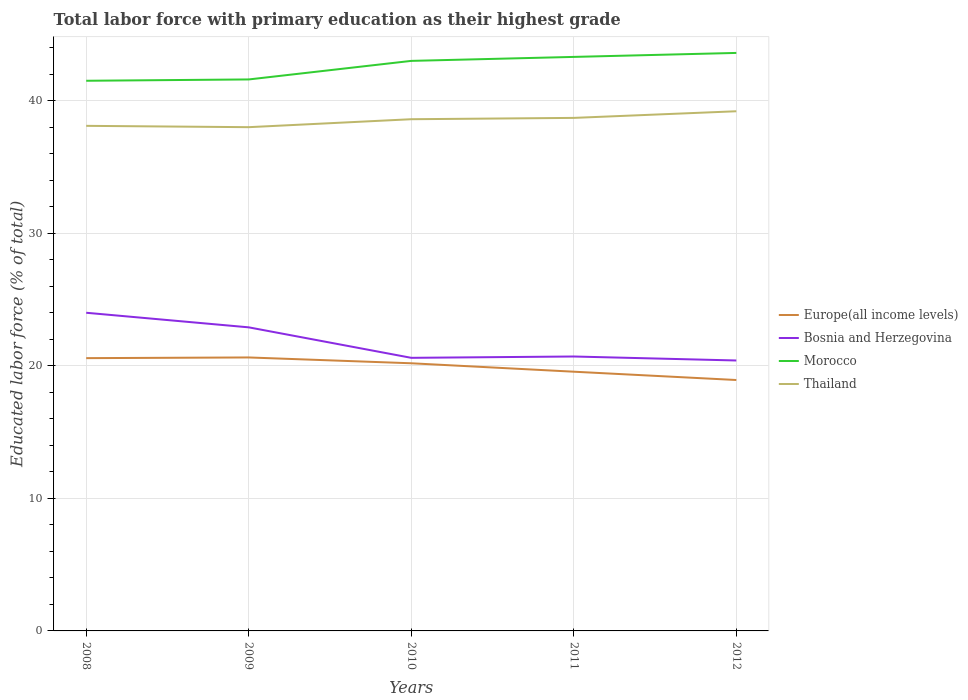Does the line corresponding to Morocco intersect with the line corresponding to Bosnia and Herzegovina?
Offer a terse response. No. Is the number of lines equal to the number of legend labels?
Your response must be concise. Yes. Across all years, what is the maximum percentage of total labor force with primary education in Morocco?
Provide a succinct answer. 41.5. In which year was the percentage of total labor force with primary education in Thailand maximum?
Provide a succinct answer. 2009. What is the total percentage of total labor force with primary education in Thailand in the graph?
Ensure brevity in your answer.  -0.6. What is the difference between the highest and the second highest percentage of total labor force with primary education in Thailand?
Offer a terse response. 1.2. Is the percentage of total labor force with primary education in Morocco strictly greater than the percentage of total labor force with primary education in Thailand over the years?
Give a very brief answer. No. How many lines are there?
Provide a short and direct response. 4. How many years are there in the graph?
Your answer should be very brief. 5. Are the values on the major ticks of Y-axis written in scientific E-notation?
Your response must be concise. No. Does the graph contain grids?
Your answer should be compact. Yes. Where does the legend appear in the graph?
Your response must be concise. Center right. How many legend labels are there?
Make the answer very short. 4. How are the legend labels stacked?
Keep it short and to the point. Vertical. What is the title of the graph?
Offer a terse response. Total labor force with primary education as their highest grade. Does "Pakistan" appear as one of the legend labels in the graph?
Keep it short and to the point. No. What is the label or title of the Y-axis?
Your answer should be compact. Educated labor force (% of total). What is the Educated labor force (% of total) in Europe(all income levels) in 2008?
Ensure brevity in your answer.  20.58. What is the Educated labor force (% of total) of Morocco in 2008?
Keep it short and to the point. 41.5. What is the Educated labor force (% of total) of Thailand in 2008?
Ensure brevity in your answer.  38.1. What is the Educated labor force (% of total) of Europe(all income levels) in 2009?
Offer a terse response. 20.63. What is the Educated labor force (% of total) of Bosnia and Herzegovina in 2009?
Give a very brief answer. 22.9. What is the Educated labor force (% of total) in Morocco in 2009?
Provide a succinct answer. 41.6. What is the Educated labor force (% of total) in Europe(all income levels) in 2010?
Give a very brief answer. 20.19. What is the Educated labor force (% of total) of Bosnia and Herzegovina in 2010?
Ensure brevity in your answer.  20.6. What is the Educated labor force (% of total) in Morocco in 2010?
Provide a succinct answer. 43. What is the Educated labor force (% of total) of Thailand in 2010?
Ensure brevity in your answer.  38.6. What is the Educated labor force (% of total) in Europe(all income levels) in 2011?
Your answer should be very brief. 19.55. What is the Educated labor force (% of total) of Bosnia and Herzegovina in 2011?
Provide a succinct answer. 20.7. What is the Educated labor force (% of total) of Morocco in 2011?
Offer a terse response. 43.3. What is the Educated labor force (% of total) of Thailand in 2011?
Your answer should be very brief. 38.7. What is the Educated labor force (% of total) in Europe(all income levels) in 2012?
Make the answer very short. 18.93. What is the Educated labor force (% of total) of Bosnia and Herzegovina in 2012?
Your response must be concise. 20.4. What is the Educated labor force (% of total) of Morocco in 2012?
Offer a terse response. 43.6. What is the Educated labor force (% of total) in Thailand in 2012?
Offer a very short reply. 39.2. Across all years, what is the maximum Educated labor force (% of total) in Europe(all income levels)?
Keep it short and to the point. 20.63. Across all years, what is the maximum Educated labor force (% of total) of Bosnia and Herzegovina?
Ensure brevity in your answer.  24. Across all years, what is the maximum Educated labor force (% of total) of Morocco?
Ensure brevity in your answer.  43.6. Across all years, what is the maximum Educated labor force (% of total) in Thailand?
Provide a succinct answer. 39.2. Across all years, what is the minimum Educated labor force (% of total) of Europe(all income levels)?
Your answer should be very brief. 18.93. Across all years, what is the minimum Educated labor force (% of total) in Bosnia and Herzegovina?
Give a very brief answer. 20.4. Across all years, what is the minimum Educated labor force (% of total) of Morocco?
Your answer should be very brief. 41.5. Across all years, what is the minimum Educated labor force (% of total) of Thailand?
Ensure brevity in your answer.  38. What is the total Educated labor force (% of total) of Europe(all income levels) in the graph?
Make the answer very short. 99.88. What is the total Educated labor force (% of total) in Bosnia and Herzegovina in the graph?
Your answer should be compact. 108.6. What is the total Educated labor force (% of total) in Morocco in the graph?
Ensure brevity in your answer.  213. What is the total Educated labor force (% of total) of Thailand in the graph?
Offer a very short reply. 192.6. What is the difference between the Educated labor force (% of total) of Europe(all income levels) in 2008 and that in 2009?
Ensure brevity in your answer.  -0.05. What is the difference between the Educated labor force (% of total) in Morocco in 2008 and that in 2009?
Keep it short and to the point. -0.1. What is the difference between the Educated labor force (% of total) of Europe(all income levels) in 2008 and that in 2010?
Provide a succinct answer. 0.39. What is the difference between the Educated labor force (% of total) of Bosnia and Herzegovina in 2008 and that in 2010?
Keep it short and to the point. 3.4. What is the difference between the Educated labor force (% of total) in Morocco in 2008 and that in 2010?
Your response must be concise. -1.5. What is the difference between the Educated labor force (% of total) in Europe(all income levels) in 2008 and that in 2011?
Your answer should be compact. 1.02. What is the difference between the Educated labor force (% of total) of Thailand in 2008 and that in 2011?
Offer a very short reply. -0.6. What is the difference between the Educated labor force (% of total) in Europe(all income levels) in 2008 and that in 2012?
Provide a succinct answer. 1.65. What is the difference between the Educated labor force (% of total) of Morocco in 2008 and that in 2012?
Your answer should be compact. -2.1. What is the difference between the Educated labor force (% of total) of Thailand in 2008 and that in 2012?
Make the answer very short. -1.1. What is the difference between the Educated labor force (% of total) of Europe(all income levels) in 2009 and that in 2010?
Provide a short and direct response. 0.44. What is the difference between the Educated labor force (% of total) of Bosnia and Herzegovina in 2009 and that in 2010?
Your response must be concise. 2.3. What is the difference between the Educated labor force (% of total) in Morocco in 2009 and that in 2010?
Offer a very short reply. -1.4. What is the difference between the Educated labor force (% of total) of Thailand in 2009 and that in 2010?
Your response must be concise. -0.6. What is the difference between the Educated labor force (% of total) of Europe(all income levels) in 2009 and that in 2011?
Ensure brevity in your answer.  1.07. What is the difference between the Educated labor force (% of total) of Thailand in 2009 and that in 2011?
Offer a very short reply. -0.7. What is the difference between the Educated labor force (% of total) in Europe(all income levels) in 2009 and that in 2012?
Make the answer very short. 1.7. What is the difference between the Educated labor force (% of total) of Bosnia and Herzegovina in 2009 and that in 2012?
Offer a terse response. 2.5. What is the difference between the Educated labor force (% of total) in Morocco in 2009 and that in 2012?
Make the answer very short. -2. What is the difference between the Educated labor force (% of total) of Europe(all income levels) in 2010 and that in 2011?
Your answer should be very brief. 0.64. What is the difference between the Educated labor force (% of total) in Morocco in 2010 and that in 2011?
Keep it short and to the point. -0.3. What is the difference between the Educated labor force (% of total) of Europe(all income levels) in 2010 and that in 2012?
Offer a very short reply. 1.26. What is the difference between the Educated labor force (% of total) of Bosnia and Herzegovina in 2010 and that in 2012?
Your response must be concise. 0.2. What is the difference between the Educated labor force (% of total) in Thailand in 2010 and that in 2012?
Your answer should be very brief. -0.6. What is the difference between the Educated labor force (% of total) of Europe(all income levels) in 2011 and that in 2012?
Give a very brief answer. 0.63. What is the difference between the Educated labor force (% of total) of Bosnia and Herzegovina in 2011 and that in 2012?
Make the answer very short. 0.3. What is the difference between the Educated labor force (% of total) in Morocco in 2011 and that in 2012?
Offer a very short reply. -0.3. What is the difference between the Educated labor force (% of total) in Thailand in 2011 and that in 2012?
Offer a terse response. -0.5. What is the difference between the Educated labor force (% of total) in Europe(all income levels) in 2008 and the Educated labor force (% of total) in Bosnia and Herzegovina in 2009?
Your answer should be very brief. -2.32. What is the difference between the Educated labor force (% of total) in Europe(all income levels) in 2008 and the Educated labor force (% of total) in Morocco in 2009?
Keep it short and to the point. -21.02. What is the difference between the Educated labor force (% of total) in Europe(all income levels) in 2008 and the Educated labor force (% of total) in Thailand in 2009?
Provide a short and direct response. -17.42. What is the difference between the Educated labor force (% of total) in Bosnia and Herzegovina in 2008 and the Educated labor force (% of total) in Morocco in 2009?
Keep it short and to the point. -17.6. What is the difference between the Educated labor force (% of total) in Morocco in 2008 and the Educated labor force (% of total) in Thailand in 2009?
Provide a succinct answer. 3.5. What is the difference between the Educated labor force (% of total) in Europe(all income levels) in 2008 and the Educated labor force (% of total) in Bosnia and Herzegovina in 2010?
Your answer should be compact. -0.02. What is the difference between the Educated labor force (% of total) of Europe(all income levels) in 2008 and the Educated labor force (% of total) of Morocco in 2010?
Offer a terse response. -22.42. What is the difference between the Educated labor force (% of total) in Europe(all income levels) in 2008 and the Educated labor force (% of total) in Thailand in 2010?
Your response must be concise. -18.02. What is the difference between the Educated labor force (% of total) of Bosnia and Herzegovina in 2008 and the Educated labor force (% of total) of Thailand in 2010?
Your response must be concise. -14.6. What is the difference between the Educated labor force (% of total) in Morocco in 2008 and the Educated labor force (% of total) in Thailand in 2010?
Your response must be concise. 2.9. What is the difference between the Educated labor force (% of total) in Europe(all income levels) in 2008 and the Educated labor force (% of total) in Bosnia and Herzegovina in 2011?
Offer a very short reply. -0.12. What is the difference between the Educated labor force (% of total) of Europe(all income levels) in 2008 and the Educated labor force (% of total) of Morocco in 2011?
Provide a short and direct response. -22.72. What is the difference between the Educated labor force (% of total) of Europe(all income levels) in 2008 and the Educated labor force (% of total) of Thailand in 2011?
Offer a terse response. -18.12. What is the difference between the Educated labor force (% of total) of Bosnia and Herzegovina in 2008 and the Educated labor force (% of total) of Morocco in 2011?
Make the answer very short. -19.3. What is the difference between the Educated labor force (% of total) of Bosnia and Herzegovina in 2008 and the Educated labor force (% of total) of Thailand in 2011?
Your answer should be compact. -14.7. What is the difference between the Educated labor force (% of total) in Morocco in 2008 and the Educated labor force (% of total) in Thailand in 2011?
Provide a succinct answer. 2.8. What is the difference between the Educated labor force (% of total) of Europe(all income levels) in 2008 and the Educated labor force (% of total) of Bosnia and Herzegovina in 2012?
Give a very brief answer. 0.18. What is the difference between the Educated labor force (% of total) in Europe(all income levels) in 2008 and the Educated labor force (% of total) in Morocco in 2012?
Give a very brief answer. -23.02. What is the difference between the Educated labor force (% of total) of Europe(all income levels) in 2008 and the Educated labor force (% of total) of Thailand in 2012?
Your response must be concise. -18.62. What is the difference between the Educated labor force (% of total) in Bosnia and Herzegovina in 2008 and the Educated labor force (% of total) in Morocco in 2012?
Your answer should be very brief. -19.6. What is the difference between the Educated labor force (% of total) in Bosnia and Herzegovina in 2008 and the Educated labor force (% of total) in Thailand in 2012?
Keep it short and to the point. -15.2. What is the difference between the Educated labor force (% of total) in Europe(all income levels) in 2009 and the Educated labor force (% of total) in Bosnia and Herzegovina in 2010?
Ensure brevity in your answer.  0.03. What is the difference between the Educated labor force (% of total) of Europe(all income levels) in 2009 and the Educated labor force (% of total) of Morocco in 2010?
Your answer should be very brief. -22.37. What is the difference between the Educated labor force (% of total) in Europe(all income levels) in 2009 and the Educated labor force (% of total) in Thailand in 2010?
Ensure brevity in your answer.  -17.97. What is the difference between the Educated labor force (% of total) in Bosnia and Herzegovina in 2009 and the Educated labor force (% of total) in Morocco in 2010?
Provide a succinct answer. -20.1. What is the difference between the Educated labor force (% of total) in Bosnia and Herzegovina in 2009 and the Educated labor force (% of total) in Thailand in 2010?
Keep it short and to the point. -15.7. What is the difference between the Educated labor force (% of total) in Morocco in 2009 and the Educated labor force (% of total) in Thailand in 2010?
Your answer should be compact. 3. What is the difference between the Educated labor force (% of total) of Europe(all income levels) in 2009 and the Educated labor force (% of total) of Bosnia and Herzegovina in 2011?
Provide a succinct answer. -0.07. What is the difference between the Educated labor force (% of total) of Europe(all income levels) in 2009 and the Educated labor force (% of total) of Morocco in 2011?
Offer a very short reply. -22.67. What is the difference between the Educated labor force (% of total) of Europe(all income levels) in 2009 and the Educated labor force (% of total) of Thailand in 2011?
Your response must be concise. -18.07. What is the difference between the Educated labor force (% of total) of Bosnia and Herzegovina in 2009 and the Educated labor force (% of total) of Morocco in 2011?
Provide a short and direct response. -20.4. What is the difference between the Educated labor force (% of total) of Bosnia and Herzegovina in 2009 and the Educated labor force (% of total) of Thailand in 2011?
Keep it short and to the point. -15.8. What is the difference between the Educated labor force (% of total) in Morocco in 2009 and the Educated labor force (% of total) in Thailand in 2011?
Your answer should be compact. 2.9. What is the difference between the Educated labor force (% of total) of Europe(all income levels) in 2009 and the Educated labor force (% of total) of Bosnia and Herzegovina in 2012?
Offer a terse response. 0.23. What is the difference between the Educated labor force (% of total) in Europe(all income levels) in 2009 and the Educated labor force (% of total) in Morocco in 2012?
Your answer should be very brief. -22.97. What is the difference between the Educated labor force (% of total) of Europe(all income levels) in 2009 and the Educated labor force (% of total) of Thailand in 2012?
Give a very brief answer. -18.57. What is the difference between the Educated labor force (% of total) of Bosnia and Herzegovina in 2009 and the Educated labor force (% of total) of Morocco in 2012?
Keep it short and to the point. -20.7. What is the difference between the Educated labor force (% of total) in Bosnia and Herzegovina in 2009 and the Educated labor force (% of total) in Thailand in 2012?
Make the answer very short. -16.3. What is the difference between the Educated labor force (% of total) in Europe(all income levels) in 2010 and the Educated labor force (% of total) in Bosnia and Herzegovina in 2011?
Keep it short and to the point. -0.51. What is the difference between the Educated labor force (% of total) in Europe(all income levels) in 2010 and the Educated labor force (% of total) in Morocco in 2011?
Ensure brevity in your answer.  -23.11. What is the difference between the Educated labor force (% of total) in Europe(all income levels) in 2010 and the Educated labor force (% of total) in Thailand in 2011?
Make the answer very short. -18.51. What is the difference between the Educated labor force (% of total) of Bosnia and Herzegovina in 2010 and the Educated labor force (% of total) of Morocco in 2011?
Provide a short and direct response. -22.7. What is the difference between the Educated labor force (% of total) of Bosnia and Herzegovina in 2010 and the Educated labor force (% of total) of Thailand in 2011?
Offer a terse response. -18.1. What is the difference between the Educated labor force (% of total) in Europe(all income levels) in 2010 and the Educated labor force (% of total) in Bosnia and Herzegovina in 2012?
Give a very brief answer. -0.21. What is the difference between the Educated labor force (% of total) of Europe(all income levels) in 2010 and the Educated labor force (% of total) of Morocco in 2012?
Offer a terse response. -23.41. What is the difference between the Educated labor force (% of total) in Europe(all income levels) in 2010 and the Educated labor force (% of total) in Thailand in 2012?
Make the answer very short. -19.01. What is the difference between the Educated labor force (% of total) in Bosnia and Herzegovina in 2010 and the Educated labor force (% of total) in Morocco in 2012?
Your response must be concise. -23. What is the difference between the Educated labor force (% of total) in Bosnia and Herzegovina in 2010 and the Educated labor force (% of total) in Thailand in 2012?
Offer a very short reply. -18.6. What is the difference between the Educated labor force (% of total) in Morocco in 2010 and the Educated labor force (% of total) in Thailand in 2012?
Your response must be concise. 3.8. What is the difference between the Educated labor force (% of total) in Europe(all income levels) in 2011 and the Educated labor force (% of total) in Bosnia and Herzegovina in 2012?
Your answer should be very brief. -0.85. What is the difference between the Educated labor force (% of total) in Europe(all income levels) in 2011 and the Educated labor force (% of total) in Morocco in 2012?
Keep it short and to the point. -24.05. What is the difference between the Educated labor force (% of total) in Europe(all income levels) in 2011 and the Educated labor force (% of total) in Thailand in 2012?
Your response must be concise. -19.65. What is the difference between the Educated labor force (% of total) in Bosnia and Herzegovina in 2011 and the Educated labor force (% of total) in Morocco in 2012?
Offer a terse response. -22.9. What is the difference between the Educated labor force (% of total) in Bosnia and Herzegovina in 2011 and the Educated labor force (% of total) in Thailand in 2012?
Provide a short and direct response. -18.5. What is the difference between the Educated labor force (% of total) in Morocco in 2011 and the Educated labor force (% of total) in Thailand in 2012?
Make the answer very short. 4.1. What is the average Educated labor force (% of total) of Europe(all income levels) per year?
Offer a very short reply. 19.98. What is the average Educated labor force (% of total) in Bosnia and Herzegovina per year?
Ensure brevity in your answer.  21.72. What is the average Educated labor force (% of total) of Morocco per year?
Offer a terse response. 42.6. What is the average Educated labor force (% of total) of Thailand per year?
Offer a terse response. 38.52. In the year 2008, what is the difference between the Educated labor force (% of total) in Europe(all income levels) and Educated labor force (% of total) in Bosnia and Herzegovina?
Your answer should be compact. -3.42. In the year 2008, what is the difference between the Educated labor force (% of total) of Europe(all income levels) and Educated labor force (% of total) of Morocco?
Give a very brief answer. -20.92. In the year 2008, what is the difference between the Educated labor force (% of total) in Europe(all income levels) and Educated labor force (% of total) in Thailand?
Make the answer very short. -17.52. In the year 2008, what is the difference between the Educated labor force (% of total) of Bosnia and Herzegovina and Educated labor force (% of total) of Morocco?
Your answer should be compact. -17.5. In the year 2008, what is the difference between the Educated labor force (% of total) in Bosnia and Herzegovina and Educated labor force (% of total) in Thailand?
Ensure brevity in your answer.  -14.1. In the year 2008, what is the difference between the Educated labor force (% of total) of Morocco and Educated labor force (% of total) of Thailand?
Provide a succinct answer. 3.4. In the year 2009, what is the difference between the Educated labor force (% of total) in Europe(all income levels) and Educated labor force (% of total) in Bosnia and Herzegovina?
Keep it short and to the point. -2.27. In the year 2009, what is the difference between the Educated labor force (% of total) in Europe(all income levels) and Educated labor force (% of total) in Morocco?
Offer a very short reply. -20.97. In the year 2009, what is the difference between the Educated labor force (% of total) of Europe(all income levels) and Educated labor force (% of total) of Thailand?
Make the answer very short. -17.37. In the year 2009, what is the difference between the Educated labor force (% of total) in Bosnia and Herzegovina and Educated labor force (% of total) in Morocco?
Keep it short and to the point. -18.7. In the year 2009, what is the difference between the Educated labor force (% of total) in Bosnia and Herzegovina and Educated labor force (% of total) in Thailand?
Give a very brief answer. -15.1. In the year 2009, what is the difference between the Educated labor force (% of total) in Morocco and Educated labor force (% of total) in Thailand?
Provide a short and direct response. 3.6. In the year 2010, what is the difference between the Educated labor force (% of total) in Europe(all income levels) and Educated labor force (% of total) in Bosnia and Herzegovina?
Make the answer very short. -0.41. In the year 2010, what is the difference between the Educated labor force (% of total) of Europe(all income levels) and Educated labor force (% of total) of Morocco?
Provide a short and direct response. -22.81. In the year 2010, what is the difference between the Educated labor force (% of total) of Europe(all income levels) and Educated labor force (% of total) of Thailand?
Your answer should be compact. -18.41. In the year 2010, what is the difference between the Educated labor force (% of total) in Bosnia and Herzegovina and Educated labor force (% of total) in Morocco?
Provide a succinct answer. -22.4. In the year 2010, what is the difference between the Educated labor force (% of total) of Bosnia and Herzegovina and Educated labor force (% of total) of Thailand?
Your answer should be compact. -18. In the year 2010, what is the difference between the Educated labor force (% of total) of Morocco and Educated labor force (% of total) of Thailand?
Offer a terse response. 4.4. In the year 2011, what is the difference between the Educated labor force (% of total) in Europe(all income levels) and Educated labor force (% of total) in Bosnia and Herzegovina?
Make the answer very short. -1.15. In the year 2011, what is the difference between the Educated labor force (% of total) in Europe(all income levels) and Educated labor force (% of total) in Morocco?
Your response must be concise. -23.75. In the year 2011, what is the difference between the Educated labor force (% of total) in Europe(all income levels) and Educated labor force (% of total) in Thailand?
Your response must be concise. -19.15. In the year 2011, what is the difference between the Educated labor force (% of total) of Bosnia and Herzegovina and Educated labor force (% of total) of Morocco?
Your response must be concise. -22.6. In the year 2011, what is the difference between the Educated labor force (% of total) in Bosnia and Herzegovina and Educated labor force (% of total) in Thailand?
Your response must be concise. -18. In the year 2011, what is the difference between the Educated labor force (% of total) in Morocco and Educated labor force (% of total) in Thailand?
Provide a succinct answer. 4.6. In the year 2012, what is the difference between the Educated labor force (% of total) of Europe(all income levels) and Educated labor force (% of total) of Bosnia and Herzegovina?
Provide a short and direct response. -1.47. In the year 2012, what is the difference between the Educated labor force (% of total) in Europe(all income levels) and Educated labor force (% of total) in Morocco?
Make the answer very short. -24.67. In the year 2012, what is the difference between the Educated labor force (% of total) in Europe(all income levels) and Educated labor force (% of total) in Thailand?
Provide a succinct answer. -20.27. In the year 2012, what is the difference between the Educated labor force (% of total) in Bosnia and Herzegovina and Educated labor force (% of total) in Morocco?
Provide a succinct answer. -23.2. In the year 2012, what is the difference between the Educated labor force (% of total) of Bosnia and Herzegovina and Educated labor force (% of total) of Thailand?
Ensure brevity in your answer.  -18.8. What is the ratio of the Educated labor force (% of total) of Europe(all income levels) in 2008 to that in 2009?
Keep it short and to the point. 1. What is the ratio of the Educated labor force (% of total) in Bosnia and Herzegovina in 2008 to that in 2009?
Keep it short and to the point. 1.05. What is the ratio of the Educated labor force (% of total) of Morocco in 2008 to that in 2009?
Give a very brief answer. 1. What is the ratio of the Educated labor force (% of total) of Thailand in 2008 to that in 2009?
Provide a succinct answer. 1. What is the ratio of the Educated labor force (% of total) of Europe(all income levels) in 2008 to that in 2010?
Ensure brevity in your answer.  1.02. What is the ratio of the Educated labor force (% of total) in Bosnia and Herzegovina in 2008 to that in 2010?
Provide a succinct answer. 1.17. What is the ratio of the Educated labor force (% of total) of Morocco in 2008 to that in 2010?
Provide a succinct answer. 0.97. What is the ratio of the Educated labor force (% of total) in Europe(all income levels) in 2008 to that in 2011?
Your response must be concise. 1.05. What is the ratio of the Educated labor force (% of total) in Bosnia and Herzegovina in 2008 to that in 2011?
Offer a terse response. 1.16. What is the ratio of the Educated labor force (% of total) in Morocco in 2008 to that in 2011?
Your answer should be compact. 0.96. What is the ratio of the Educated labor force (% of total) of Thailand in 2008 to that in 2011?
Make the answer very short. 0.98. What is the ratio of the Educated labor force (% of total) of Europe(all income levels) in 2008 to that in 2012?
Offer a very short reply. 1.09. What is the ratio of the Educated labor force (% of total) in Bosnia and Herzegovina in 2008 to that in 2012?
Provide a short and direct response. 1.18. What is the ratio of the Educated labor force (% of total) in Morocco in 2008 to that in 2012?
Provide a succinct answer. 0.95. What is the ratio of the Educated labor force (% of total) in Thailand in 2008 to that in 2012?
Provide a succinct answer. 0.97. What is the ratio of the Educated labor force (% of total) of Europe(all income levels) in 2009 to that in 2010?
Ensure brevity in your answer.  1.02. What is the ratio of the Educated labor force (% of total) in Bosnia and Herzegovina in 2009 to that in 2010?
Give a very brief answer. 1.11. What is the ratio of the Educated labor force (% of total) in Morocco in 2009 to that in 2010?
Offer a terse response. 0.97. What is the ratio of the Educated labor force (% of total) in Thailand in 2009 to that in 2010?
Give a very brief answer. 0.98. What is the ratio of the Educated labor force (% of total) of Europe(all income levels) in 2009 to that in 2011?
Your response must be concise. 1.05. What is the ratio of the Educated labor force (% of total) of Bosnia and Herzegovina in 2009 to that in 2011?
Your answer should be compact. 1.11. What is the ratio of the Educated labor force (% of total) in Morocco in 2009 to that in 2011?
Your answer should be very brief. 0.96. What is the ratio of the Educated labor force (% of total) of Thailand in 2009 to that in 2011?
Make the answer very short. 0.98. What is the ratio of the Educated labor force (% of total) in Europe(all income levels) in 2009 to that in 2012?
Keep it short and to the point. 1.09. What is the ratio of the Educated labor force (% of total) of Bosnia and Herzegovina in 2009 to that in 2012?
Your answer should be very brief. 1.12. What is the ratio of the Educated labor force (% of total) in Morocco in 2009 to that in 2012?
Keep it short and to the point. 0.95. What is the ratio of the Educated labor force (% of total) of Thailand in 2009 to that in 2012?
Your answer should be very brief. 0.97. What is the ratio of the Educated labor force (% of total) of Europe(all income levels) in 2010 to that in 2011?
Your response must be concise. 1.03. What is the ratio of the Educated labor force (% of total) of Bosnia and Herzegovina in 2010 to that in 2011?
Offer a terse response. 1. What is the ratio of the Educated labor force (% of total) in Morocco in 2010 to that in 2011?
Ensure brevity in your answer.  0.99. What is the ratio of the Educated labor force (% of total) in Thailand in 2010 to that in 2011?
Your response must be concise. 1. What is the ratio of the Educated labor force (% of total) of Europe(all income levels) in 2010 to that in 2012?
Ensure brevity in your answer.  1.07. What is the ratio of the Educated labor force (% of total) in Bosnia and Herzegovina in 2010 to that in 2012?
Ensure brevity in your answer.  1.01. What is the ratio of the Educated labor force (% of total) of Morocco in 2010 to that in 2012?
Keep it short and to the point. 0.99. What is the ratio of the Educated labor force (% of total) of Thailand in 2010 to that in 2012?
Make the answer very short. 0.98. What is the ratio of the Educated labor force (% of total) in Europe(all income levels) in 2011 to that in 2012?
Your response must be concise. 1.03. What is the ratio of the Educated labor force (% of total) of Bosnia and Herzegovina in 2011 to that in 2012?
Your response must be concise. 1.01. What is the ratio of the Educated labor force (% of total) in Morocco in 2011 to that in 2012?
Ensure brevity in your answer.  0.99. What is the ratio of the Educated labor force (% of total) in Thailand in 2011 to that in 2012?
Your response must be concise. 0.99. What is the difference between the highest and the second highest Educated labor force (% of total) in Europe(all income levels)?
Make the answer very short. 0.05. What is the difference between the highest and the second highest Educated labor force (% of total) in Bosnia and Herzegovina?
Give a very brief answer. 1.1. What is the difference between the highest and the second highest Educated labor force (% of total) of Morocco?
Make the answer very short. 0.3. What is the difference between the highest and the second highest Educated labor force (% of total) of Thailand?
Your answer should be very brief. 0.5. What is the difference between the highest and the lowest Educated labor force (% of total) in Europe(all income levels)?
Keep it short and to the point. 1.7. 